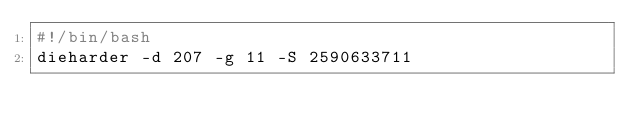<code> <loc_0><loc_0><loc_500><loc_500><_Bash_>#!/bin/bash
dieharder -d 207 -g 11 -S 2590633711
</code> 